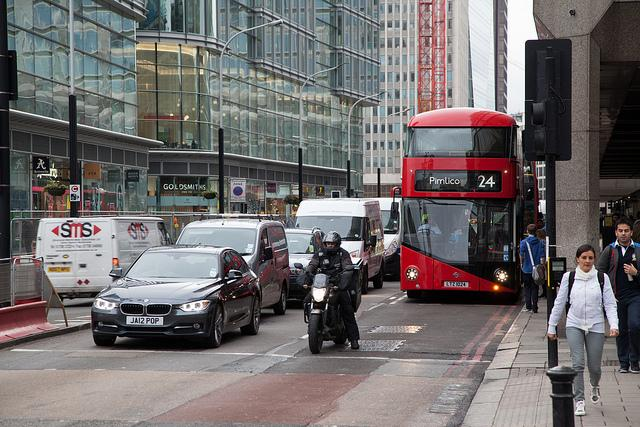What area of London does the bus go to?

Choices:
A) south
B) west
C) central
D) north central 